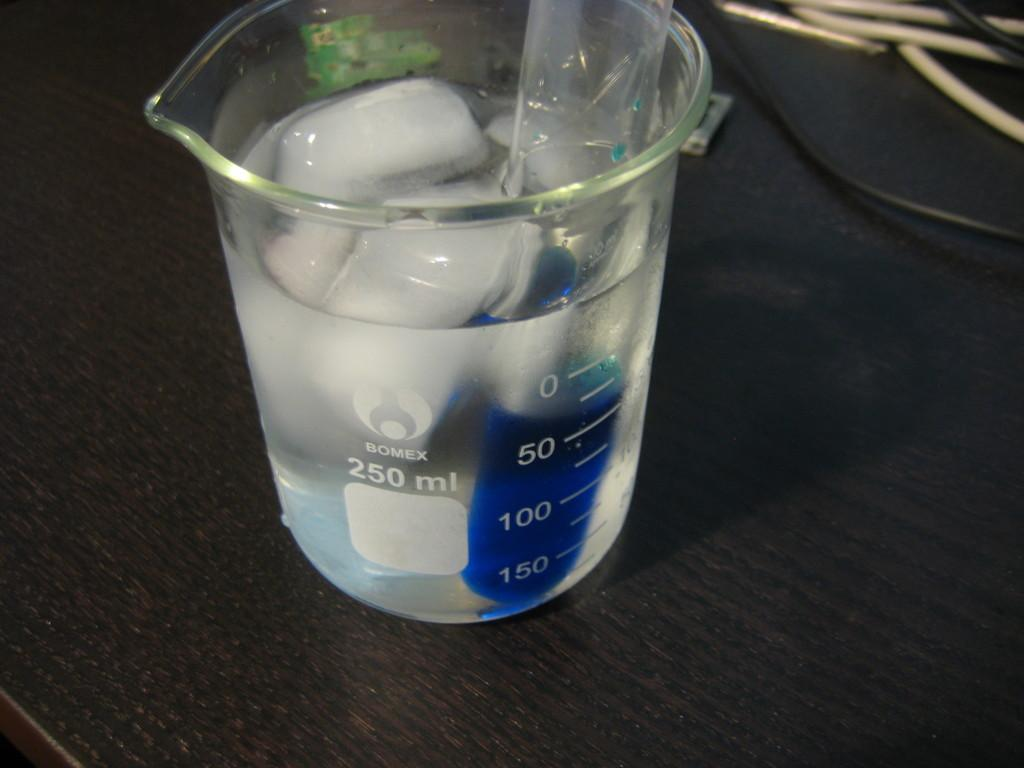<image>
Create a compact narrative representing the image presented. A  250ml  glass beaker with what looks like ice suspended in water. 